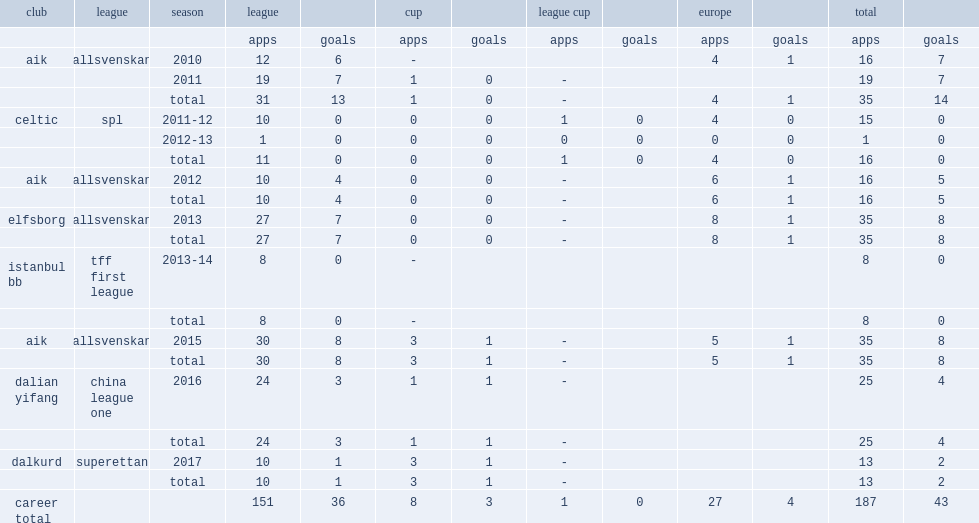When did bangura join dalkurd in superettan? 2017.0. 